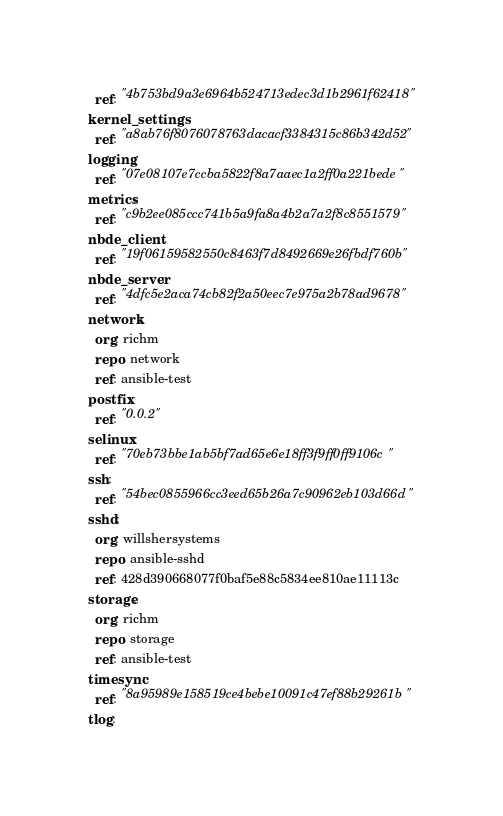Convert code to text. <code><loc_0><loc_0><loc_500><loc_500><_YAML_>  ref: "4b753bd9a3e6964b524713edec3d1b2961f62418"
kernel_settings:
  ref: "a8ab76f8076078763dacacf3384315c86b342d52"
logging:
  ref: "07e08107e7ccba5822f8a7aaec1a2ff0a221bede"
metrics:
  ref: "c9b2ee085ccc741b5a9fa8a4b2a7a2f8c8551579"
nbde_client:
  ref: "19f06159582550c8463f7d8492669e26fbdf760b"
nbde_server:
  ref: "4dfc5e2aca74cb82f2a50eec7e975a2b78ad9678"
network:
  org: richm
  repo: network
  ref: ansible-test
postfix:
  ref: "0.0.2"
selinux:
  ref: "70eb73bbe1ab5bf7ad65e6e18ff3f9ff0ff9106c"
ssh:
  ref: "54bec0855966cc3eed65b26a7c90962eb103d66d"
sshd:
  org: willshersystems
  repo: ansible-sshd
  ref: 428d390668077f0baf5e88c5834ee810ae11113c
storage:
  org: richm
  repo: storage
  ref: ansible-test
timesync:
  ref: "8a95989e158519ce4bebe10091c47ef88b29261b"
tlog:</code> 